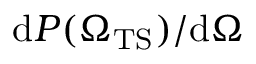Convert formula to latex. <formula><loc_0><loc_0><loc_500><loc_500>d P ( { \Omega _ { T S } ) } / d \Omega</formula> 